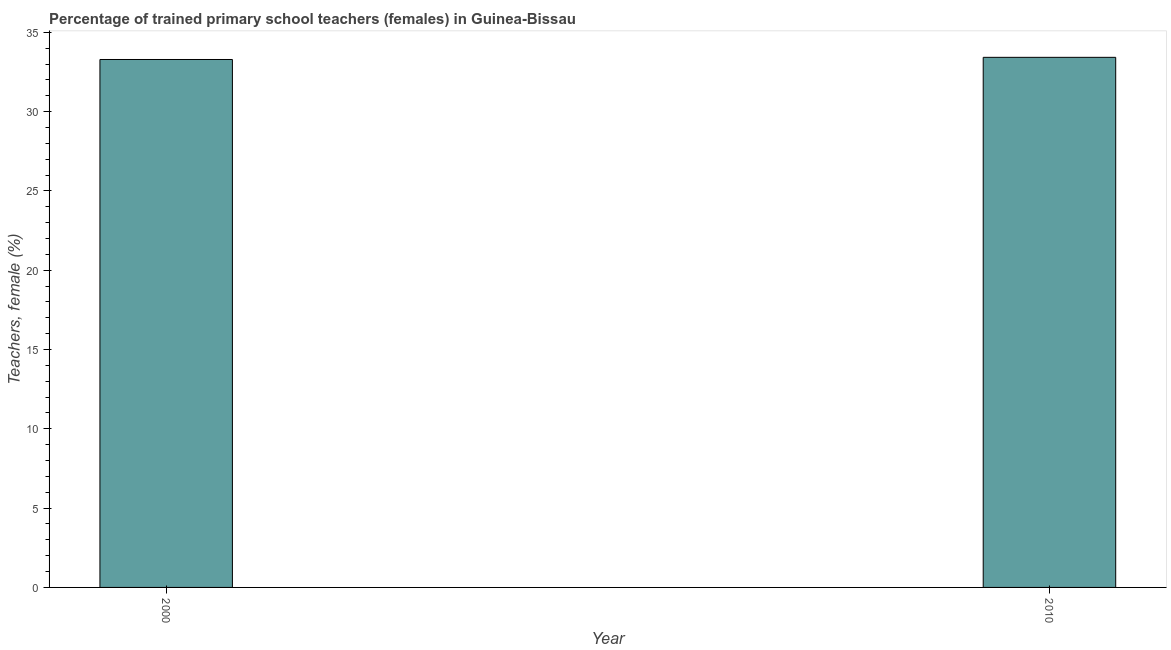Does the graph contain any zero values?
Keep it short and to the point. No. What is the title of the graph?
Your response must be concise. Percentage of trained primary school teachers (females) in Guinea-Bissau. What is the label or title of the X-axis?
Your answer should be compact. Year. What is the label or title of the Y-axis?
Provide a succinct answer. Teachers, female (%). What is the percentage of trained female teachers in 2010?
Make the answer very short. 33.42. Across all years, what is the maximum percentage of trained female teachers?
Your response must be concise. 33.42. Across all years, what is the minimum percentage of trained female teachers?
Your answer should be very brief. 33.28. In which year was the percentage of trained female teachers maximum?
Offer a very short reply. 2010. What is the sum of the percentage of trained female teachers?
Your response must be concise. 66.7. What is the difference between the percentage of trained female teachers in 2000 and 2010?
Your answer should be very brief. -0.14. What is the average percentage of trained female teachers per year?
Your answer should be very brief. 33.35. What is the median percentage of trained female teachers?
Your answer should be compact. 33.35. In how many years, is the percentage of trained female teachers greater than 4 %?
Make the answer very short. 2. Is the percentage of trained female teachers in 2000 less than that in 2010?
Your answer should be very brief. Yes. In how many years, is the percentage of trained female teachers greater than the average percentage of trained female teachers taken over all years?
Your response must be concise. 1. How many bars are there?
Provide a succinct answer. 2. What is the difference between two consecutive major ticks on the Y-axis?
Make the answer very short. 5. What is the Teachers, female (%) of 2000?
Make the answer very short. 33.28. What is the Teachers, female (%) of 2010?
Make the answer very short. 33.42. What is the difference between the Teachers, female (%) in 2000 and 2010?
Offer a very short reply. -0.14. 